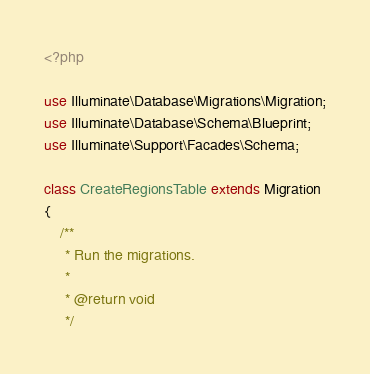Convert code to text. <code><loc_0><loc_0><loc_500><loc_500><_PHP_><?php

use Illuminate\Database\Migrations\Migration;
use Illuminate\Database\Schema\Blueprint;
use Illuminate\Support\Facades\Schema;

class CreateRegionsTable extends Migration
{
    /**
     * Run the migrations.
     *
     * @return void
     */</code> 